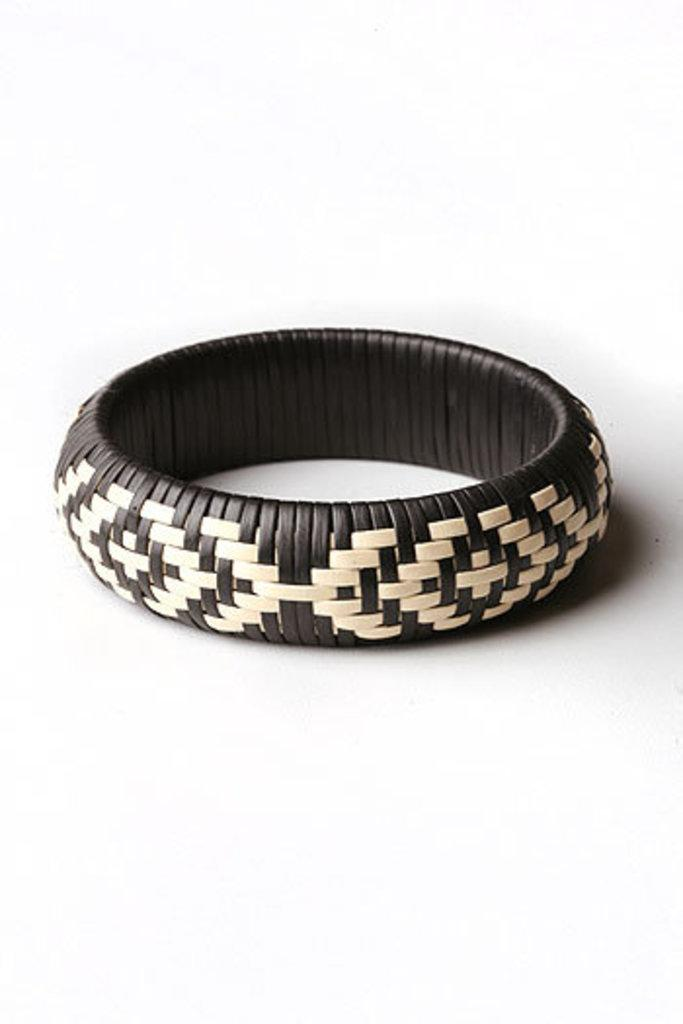What is the main object in the image? There is a bangle in the image. Can you describe the appearance of the bangle? The bangle is made up of white and black color threads. What caption is written on the bangle in the image? There is no caption written on the bangle in the image. Can you tell me what instrument the person wearing the bangle is playing? There is no person wearing the bangle or playing an instrument in the image. 